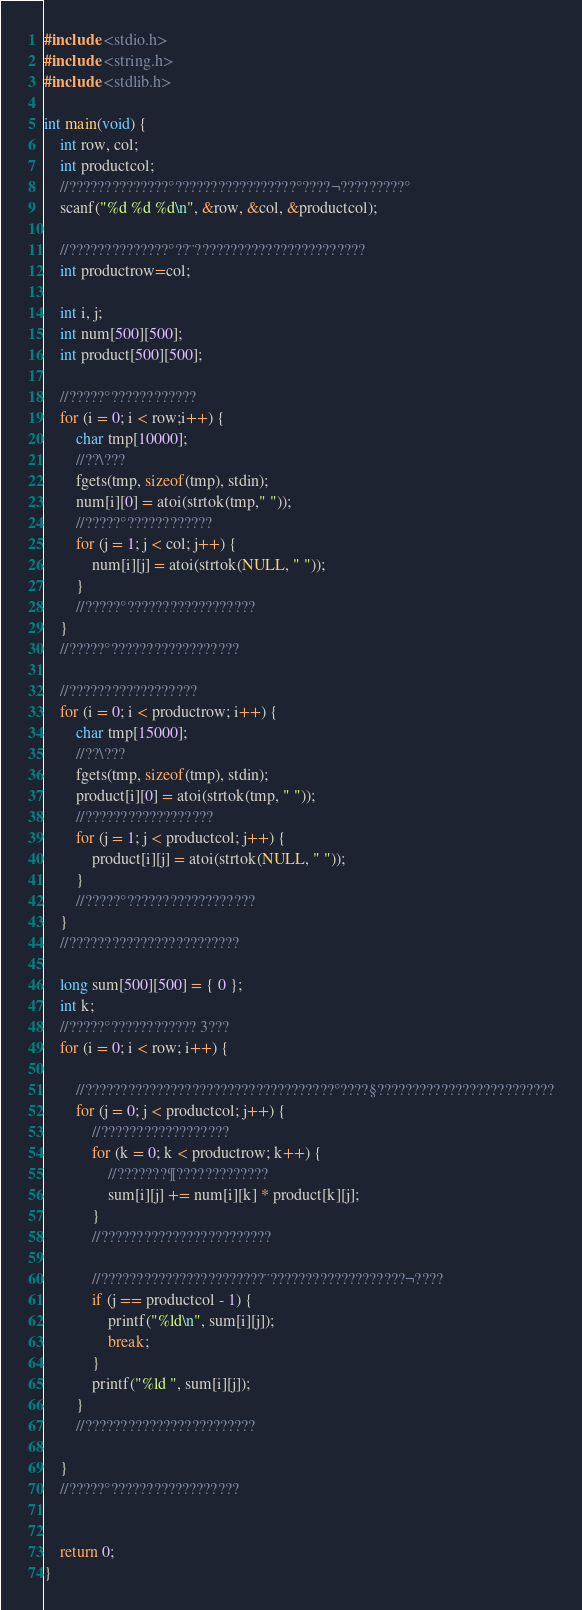<code> <loc_0><loc_0><loc_500><loc_500><_C_>#include <stdio.h>
#include <string.h>
#include <stdlib.h>

int main(void) {
	int row, col;
	int productcol;
	//??????????????°?????????????????°????¬?????????°
	scanf("%d %d %d\n", &row, &col, &productcol);

	//??????????????°??¨????????????????????????
	int productrow=col;

	int i, j;
	int num[500][500];
	int product[500][500];

	//?????°????????????
	for (i = 0; i < row;i++) {
		char tmp[10000];
		//??\???
		fgets(tmp, sizeof(tmp), stdin);
		num[i][0] = atoi(strtok(tmp," "));
		//?????°????????????
		for (j = 1; j < col; j++) {
			num[i][j] = atoi(strtok(NULL, " "));
		}
		//?????°??????????????????
	}
	//?????°??????????????????

	//??????????????????
	for (i = 0; i < productrow; i++) {
		char tmp[15000];
		//??\???
		fgets(tmp, sizeof(tmp), stdin);
		product[i][0] = atoi(strtok(tmp, " "));
		//??????????????????
		for (j = 1; j < productcol; j++) {
			product[i][j] = atoi(strtok(NULL, " "));
		}
		//?????°??????????????????
	}
	//????????????????????????

	long sum[500][500] = { 0 };
	int k;
	//?????°???????????? 3???
	for (i = 0; i < row; i++) {

		//???????????????????????????????????°????§?????????????????????????
		for (j = 0; j < productcol; j++) {
			//??????????????????
			for (k = 0; k < productrow; k++) {
				//???????¶?????????????
				sum[i][j] += num[i][k] * product[k][j];
			}
			//????????????????????????
				
			//???????????????????????¨???????????????????¬????
			if (j == productcol - 1) {
				printf("%ld\n", sum[i][j]);
				break;
			}
			printf("%ld ", sum[i][j]);
		}
		//????????????????????????

	}
	//?????°??????????????????


	return 0;
}</code> 